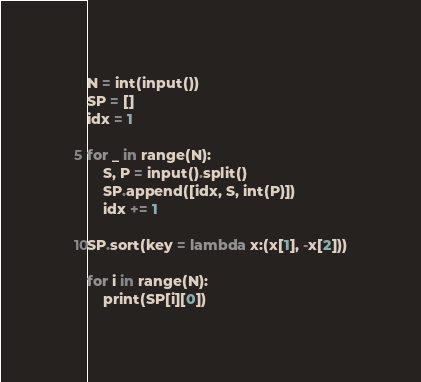<code> <loc_0><loc_0><loc_500><loc_500><_Python_>N = int(input())
SP = []
idx = 1

for _ in range(N):
	S, P = input().split()
	SP.append([idx, S, int(P)])
	idx += 1

SP.sort(key = lambda x:(x[1], -x[2]))

for i in range(N):
	print(SP[i][0])</code> 